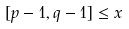<formula> <loc_0><loc_0><loc_500><loc_500>[ p - 1 , q - 1 ] \leq x</formula> 